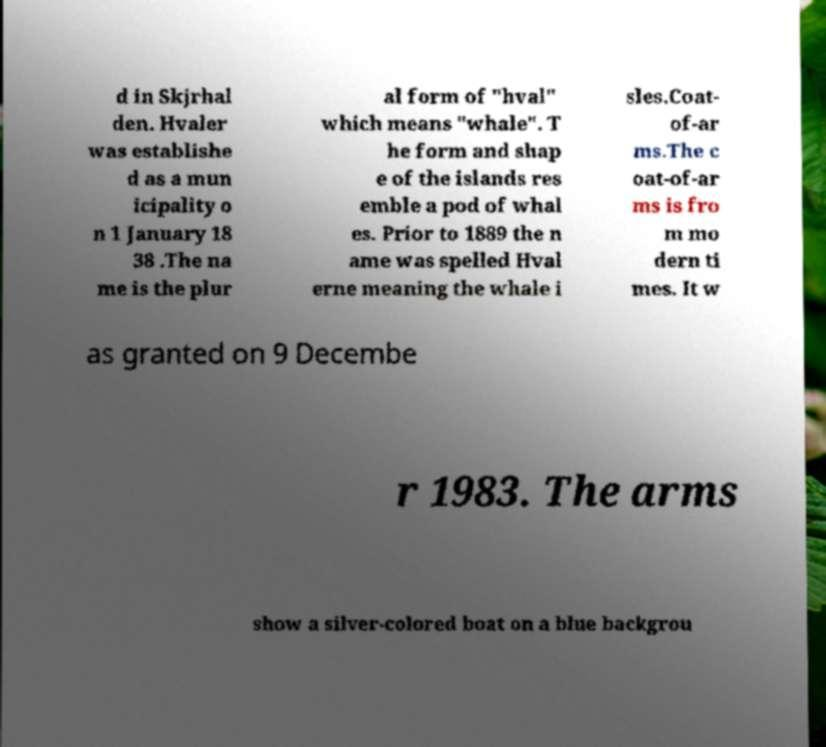Please identify and transcribe the text found in this image. d in Skjrhal den. Hvaler was establishe d as a mun icipality o n 1 January 18 38 .The na me is the plur al form of "hval" which means "whale". T he form and shap e of the islands res emble a pod of whal es. Prior to 1889 the n ame was spelled Hval erne meaning the whale i sles.Coat- of-ar ms.The c oat-of-ar ms is fro m mo dern ti mes. It w as granted on 9 Decembe r 1983. The arms show a silver-colored boat on a blue backgrou 